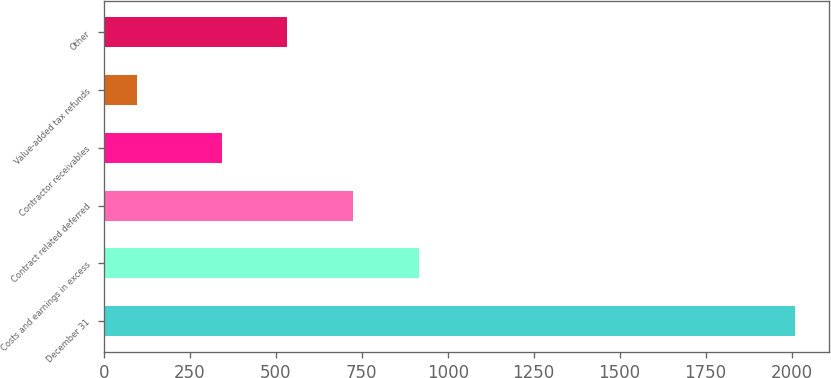<chart> <loc_0><loc_0><loc_500><loc_500><bar_chart><fcel>December 31<fcel>Costs and earnings in excess<fcel>Contract related deferred<fcel>Contractor receivables<fcel>Value-added tax refunds<fcel>Other<nl><fcel>2009<fcel>916.2<fcel>724.8<fcel>342<fcel>95<fcel>533.4<nl></chart> 